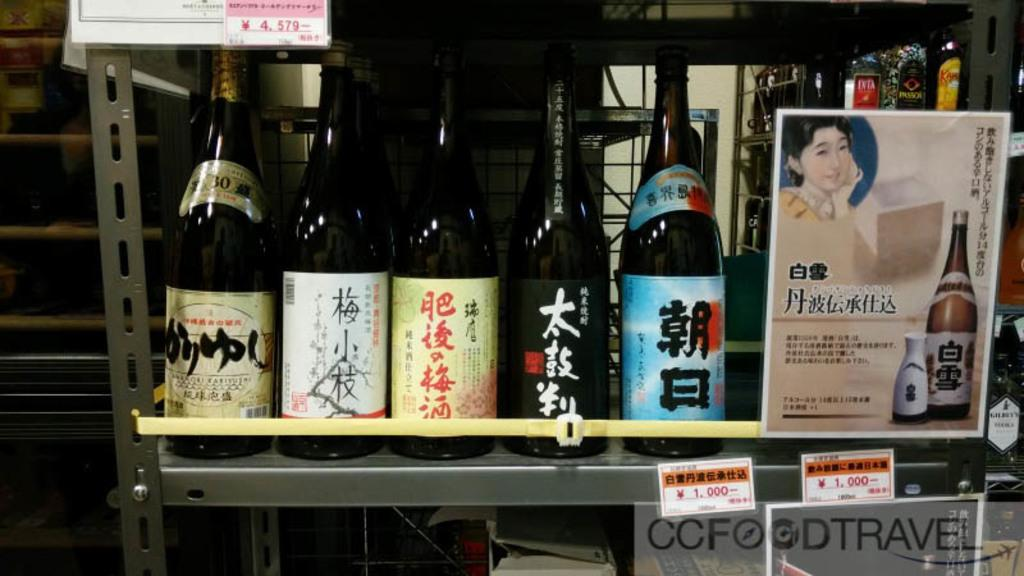How many bottles are visible in the image? There are four bottles in the image. How are the bottles arranged in the image? The bottles are arranged in a row. What else can be seen beside the bottles? There is a sticker beside the bottles. What type of produce is being harvested in the image? There is no produce visible in the image; it only features four bottles arranged in a row and a sticker beside them. 